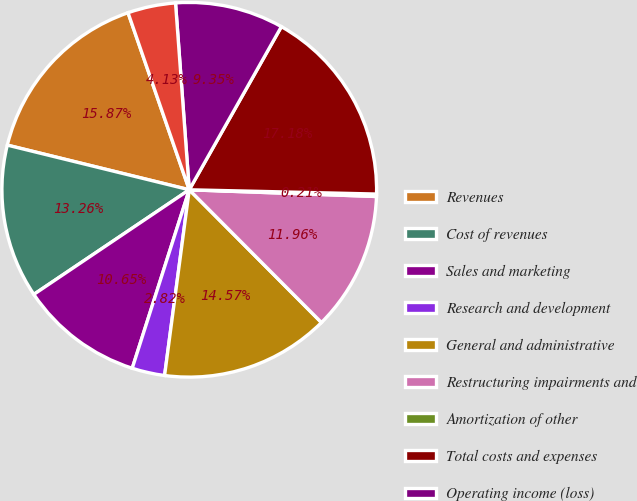Convert chart to OTSL. <chart><loc_0><loc_0><loc_500><loc_500><pie_chart><fcel>Revenues<fcel>Cost of revenues<fcel>Sales and marketing<fcel>Research and development<fcel>General and administrative<fcel>Restructuring impairments and<fcel>Amortization of other<fcel>Total costs and expenses<fcel>Operating income (loss)<fcel>Other (loss) income net<nl><fcel>15.87%<fcel>13.26%<fcel>10.65%<fcel>2.82%<fcel>14.57%<fcel>11.96%<fcel>0.21%<fcel>17.18%<fcel>9.35%<fcel>4.13%<nl></chart> 